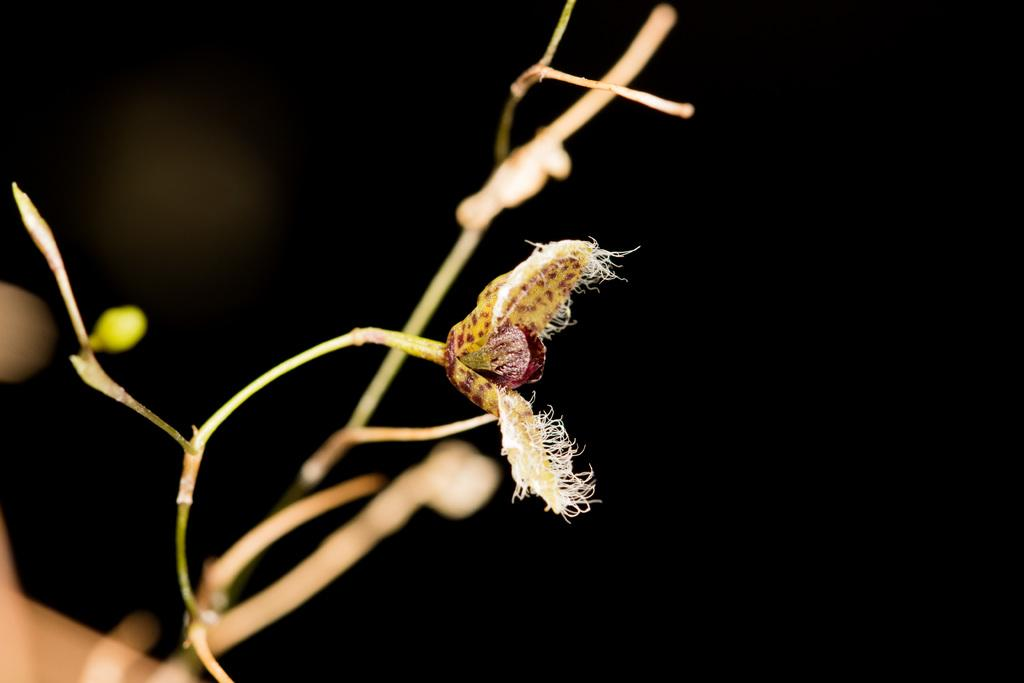What type of plant is visible in the image? There is a plant with a bud in the image. Can you describe the background of the image? The background of the image is dark and blurry. What type of pan is hanging on the boot in the image? There is no pan or boot present in the image; it only features a plant with a bud and a dark, blurry background. 